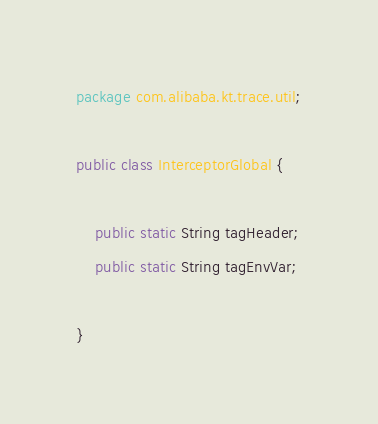Convert code to text. <code><loc_0><loc_0><loc_500><loc_500><_Java_>package com.alibaba.kt.trace.util;

public class InterceptorGlobal {

    public static String tagHeader;
    public static String tagEnvVar;

}
</code> 